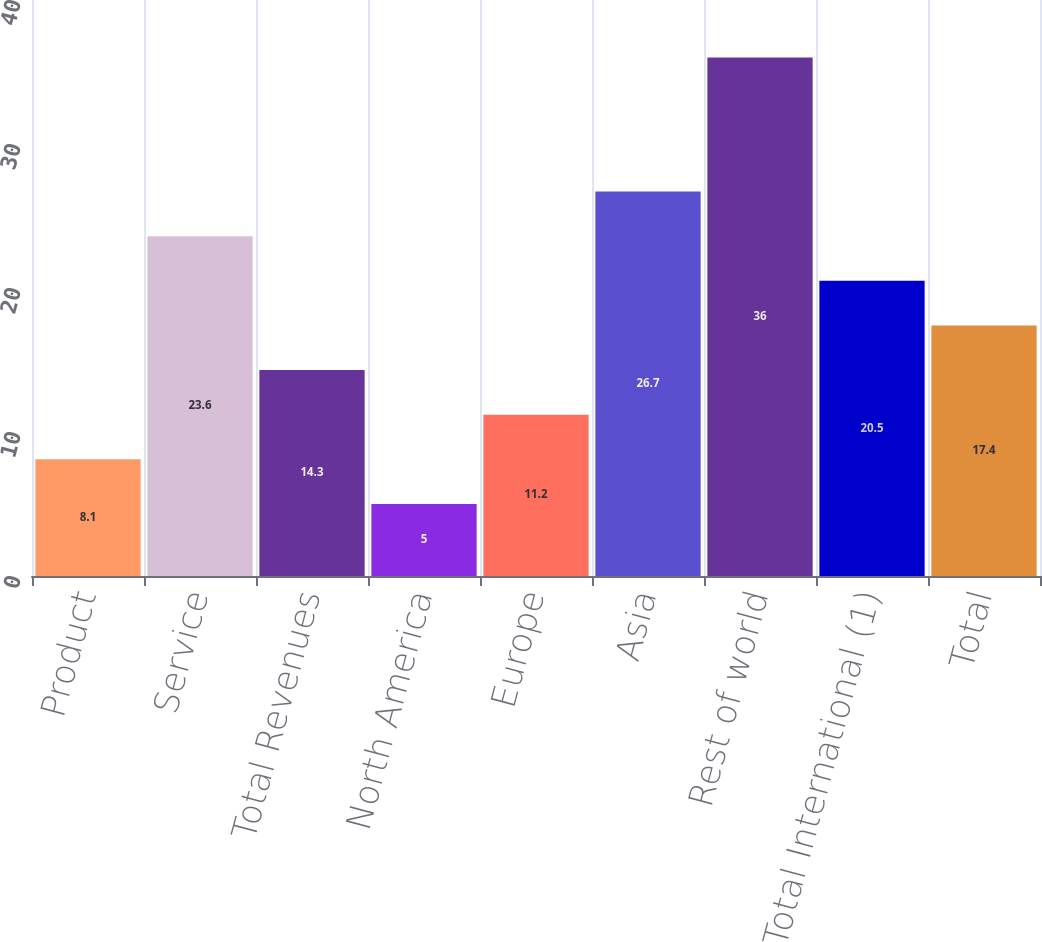Convert chart. <chart><loc_0><loc_0><loc_500><loc_500><bar_chart><fcel>Product<fcel>Service<fcel>Total Revenues<fcel>North America<fcel>Europe<fcel>Asia<fcel>Rest of world<fcel>Total International (1)<fcel>Total<nl><fcel>8.1<fcel>23.6<fcel>14.3<fcel>5<fcel>11.2<fcel>26.7<fcel>36<fcel>20.5<fcel>17.4<nl></chart> 